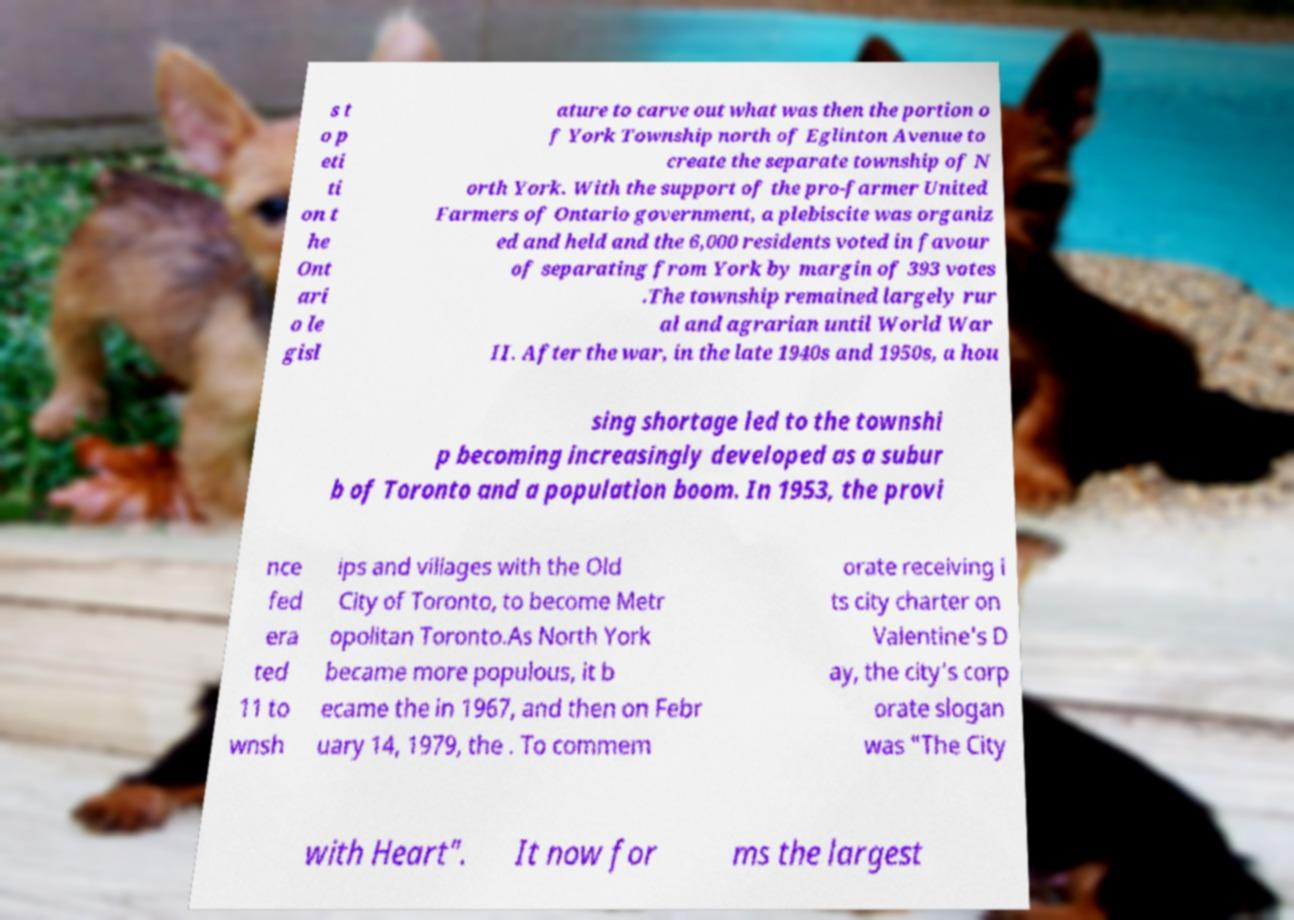I need the written content from this picture converted into text. Can you do that? s t o p eti ti on t he Ont ari o le gisl ature to carve out what was then the portion o f York Township north of Eglinton Avenue to create the separate township of N orth York. With the support of the pro-farmer United Farmers of Ontario government, a plebiscite was organiz ed and held and the 6,000 residents voted in favour of separating from York by margin of 393 votes .The township remained largely rur al and agrarian until World War II. After the war, in the late 1940s and 1950s, a hou sing shortage led to the townshi p becoming increasingly developed as a subur b of Toronto and a population boom. In 1953, the provi nce fed era ted 11 to wnsh ips and villages with the Old City of Toronto, to become Metr opolitan Toronto.As North York became more populous, it b ecame the in 1967, and then on Febr uary 14, 1979, the . To commem orate receiving i ts city charter on Valentine's D ay, the city's corp orate slogan was "The City with Heart". It now for ms the largest 